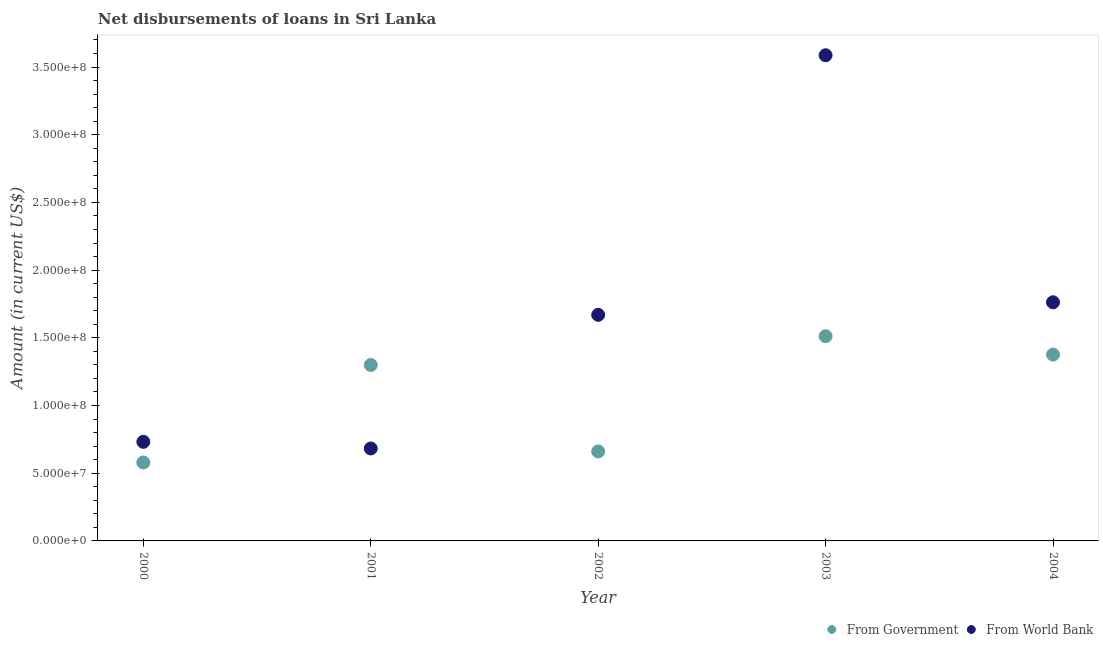How many different coloured dotlines are there?
Offer a very short reply. 2. What is the net disbursements of loan from government in 2004?
Make the answer very short. 1.38e+08. Across all years, what is the maximum net disbursements of loan from world bank?
Ensure brevity in your answer.  3.59e+08. Across all years, what is the minimum net disbursements of loan from world bank?
Ensure brevity in your answer.  6.83e+07. What is the total net disbursements of loan from government in the graph?
Offer a terse response. 5.43e+08. What is the difference between the net disbursements of loan from government in 2002 and that in 2003?
Give a very brief answer. -8.51e+07. What is the difference between the net disbursements of loan from world bank in 2003 and the net disbursements of loan from government in 2001?
Ensure brevity in your answer.  2.29e+08. What is the average net disbursements of loan from world bank per year?
Offer a very short reply. 1.69e+08. In the year 2000, what is the difference between the net disbursements of loan from world bank and net disbursements of loan from government?
Provide a short and direct response. 1.53e+07. What is the ratio of the net disbursements of loan from world bank in 2001 to that in 2003?
Your answer should be compact. 0.19. Is the net disbursements of loan from world bank in 2000 less than that in 2003?
Offer a very short reply. Yes. Is the difference between the net disbursements of loan from government in 2002 and 2004 greater than the difference between the net disbursements of loan from world bank in 2002 and 2004?
Ensure brevity in your answer.  No. What is the difference between the highest and the second highest net disbursements of loan from world bank?
Ensure brevity in your answer.  1.82e+08. What is the difference between the highest and the lowest net disbursements of loan from world bank?
Make the answer very short. 2.90e+08. Is the sum of the net disbursements of loan from government in 2000 and 2002 greater than the maximum net disbursements of loan from world bank across all years?
Ensure brevity in your answer.  No. Is the net disbursements of loan from world bank strictly less than the net disbursements of loan from government over the years?
Make the answer very short. No. How many dotlines are there?
Ensure brevity in your answer.  2. What is the difference between two consecutive major ticks on the Y-axis?
Give a very brief answer. 5.00e+07. Does the graph contain any zero values?
Provide a succinct answer. No. Does the graph contain grids?
Provide a succinct answer. No. How many legend labels are there?
Make the answer very short. 2. How are the legend labels stacked?
Offer a terse response. Horizontal. What is the title of the graph?
Keep it short and to the point. Net disbursements of loans in Sri Lanka. What is the Amount (in current US$) in From Government in 2000?
Your answer should be compact. 5.79e+07. What is the Amount (in current US$) in From World Bank in 2000?
Ensure brevity in your answer.  7.32e+07. What is the Amount (in current US$) in From Government in 2001?
Offer a terse response. 1.30e+08. What is the Amount (in current US$) in From World Bank in 2001?
Offer a very short reply. 6.83e+07. What is the Amount (in current US$) in From Government in 2002?
Ensure brevity in your answer.  6.61e+07. What is the Amount (in current US$) in From World Bank in 2002?
Give a very brief answer. 1.67e+08. What is the Amount (in current US$) in From Government in 2003?
Make the answer very short. 1.51e+08. What is the Amount (in current US$) in From World Bank in 2003?
Ensure brevity in your answer.  3.59e+08. What is the Amount (in current US$) in From Government in 2004?
Your answer should be very brief. 1.38e+08. What is the Amount (in current US$) of From World Bank in 2004?
Your answer should be compact. 1.76e+08. Across all years, what is the maximum Amount (in current US$) in From Government?
Offer a very short reply. 1.51e+08. Across all years, what is the maximum Amount (in current US$) of From World Bank?
Provide a short and direct response. 3.59e+08. Across all years, what is the minimum Amount (in current US$) of From Government?
Offer a very short reply. 5.79e+07. Across all years, what is the minimum Amount (in current US$) of From World Bank?
Make the answer very short. 6.83e+07. What is the total Amount (in current US$) of From Government in the graph?
Your response must be concise. 5.43e+08. What is the total Amount (in current US$) of From World Bank in the graph?
Your answer should be compact. 8.43e+08. What is the difference between the Amount (in current US$) in From Government in 2000 and that in 2001?
Make the answer very short. -7.20e+07. What is the difference between the Amount (in current US$) in From World Bank in 2000 and that in 2001?
Your answer should be very brief. 4.90e+06. What is the difference between the Amount (in current US$) of From Government in 2000 and that in 2002?
Ensure brevity in your answer.  -8.20e+06. What is the difference between the Amount (in current US$) of From World Bank in 2000 and that in 2002?
Make the answer very short. -9.38e+07. What is the difference between the Amount (in current US$) of From Government in 2000 and that in 2003?
Give a very brief answer. -9.33e+07. What is the difference between the Amount (in current US$) in From World Bank in 2000 and that in 2003?
Make the answer very short. -2.86e+08. What is the difference between the Amount (in current US$) in From Government in 2000 and that in 2004?
Ensure brevity in your answer.  -7.97e+07. What is the difference between the Amount (in current US$) of From World Bank in 2000 and that in 2004?
Ensure brevity in your answer.  -1.03e+08. What is the difference between the Amount (in current US$) of From Government in 2001 and that in 2002?
Provide a short and direct response. 6.38e+07. What is the difference between the Amount (in current US$) of From World Bank in 2001 and that in 2002?
Offer a very short reply. -9.87e+07. What is the difference between the Amount (in current US$) in From Government in 2001 and that in 2003?
Provide a succinct answer. -2.13e+07. What is the difference between the Amount (in current US$) in From World Bank in 2001 and that in 2003?
Offer a very short reply. -2.90e+08. What is the difference between the Amount (in current US$) in From Government in 2001 and that in 2004?
Your answer should be compact. -7.67e+06. What is the difference between the Amount (in current US$) of From World Bank in 2001 and that in 2004?
Provide a succinct answer. -1.08e+08. What is the difference between the Amount (in current US$) in From Government in 2002 and that in 2003?
Offer a terse response. -8.51e+07. What is the difference between the Amount (in current US$) in From World Bank in 2002 and that in 2003?
Offer a very short reply. -1.92e+08. What is the difference between the Amount (in current US$) in From Government in 2002 and that in 2004?
Your answer should be very brief. -7.15e+07. What is the difference between the Amount (in current US$) of From World Bank in 2002 and that in 2004?
Give a very brief answer. -9.26e+06. What is the difference between the Amount (in current US$) of From Government in 2003 and that in 2004?
Your answer should be compact. 1.36e+07. What is the difference between the Amount (in current US$) in From World Bank in 2003 and that in 2004?
Offer a terse response. 1.82e+08. What is the difference between the Amount (in current US$) in From Government in 2000 and the Amount (in current US$) in From World Bank in 2001?
Your response must be concise. -1.04e+07. What is the difference between the Amount (in current US$) of From Government in 2000 and the Amount (in current US$) of From World Bank in 2002?
Your answer should be very brief. -1.09e+08. What is the difference between the Amount (in current US$) of From Government in 2000 and the Amount (in current US$) of From World Bank in 2003?
Provide a short and direct response. -3.01e+08. What is the difference between the Amount (in current US$) of From Government in 2000 and the Amount (in current US$) of From World Bank in 2004?
Provide a succinct answer. -1.18e+08. What is the difference between the Amount (in current US$) of From Government in 2001 and the Amount (in current US$) of From World Bank in 2002?
Provide a short and direct response. -3.70e+07. What is the difference between the Amount (in current US$) of From Government in 2001 and the Amount (in current US$) of From World Bank in 2003?
Provide a short and direct response. -2.29e+08. What is the difference between the Amount (in current US$) of From Government in 2001 and the Amount (in current US$) of From World Bank in 2004?
Provide a short and direct response. -4.63e+07. What is the difference between the Amount (in current US$) in From Government in 2002 and the Amount (in current US$) in From World Bank in 2003?
Offer a very short reply. -2.93e+08. What is the difference between the Amount (in current US$) of From Government in 2002 and the Amount (in current US$) of From World Bank in 2004?
Ensure brevity in your answer.  -1.10e+08. What is the difference between the Amount (in current US$) of From Government in 2003 and the Amount (in current US$) of From World Bank in 2004?
Provide a short and direct response. -2.50e+07. What is the average Amount (in current US$) in From Government per year?
Make the answer very short. 1.09e+08. What is the average Amount (in current US$) of From World Bank per year?
Keep it short and to the point. 1.69e+08. In the year 2000, what is the difference between the Amount (in current US$) in From Government and Amount (in current US$) in From World Bank?
Your answer should be compact. -1.53e+07. In the year 2001, what is the difference between the Amount (in current US$) in From Government and Amount (in current US$) in From World Bank?
Your answer should be very brief. 6.17e+07. In the year 2002, what is the difference between the Amount (in current US$) of From Government and Amount (in current US$) of From World Bank?
Your answer should be very brief. -1.01e+08. In the year 2003, what is the difference between the Amount (in current US$) in From Government and Amount (in current US$) in From World Bank?
Offer a terse response. -2.08e+08. In the year 2004, what is the difference between the Amount (in current US$) in From Government and Amount (in current US$) in From World Bank?
Offer a terse response. -3.86e+07. What is the ratio of the Amount (in current US$) in From Government in 2000 to that in 2001?
Make the answer very short. 0.45. What is the ratio of the Amount (in current US$) of From World Bank in 2000 to that in 2001?
Offer a terse response. 1.07. What is the ratio of the Amount (in current US$) in From Government in 2000 to that in 2002?
Your answer should be compact. 0.88. What is the ratio of the Amount (in current US$) of From World Bank in 2000 to that in 2002?
Your response must be concise. 0.44. What is the ratio of the Amount (in current US$) in From Government in 2000 to that in 2003?
Provide a succinct answer. 0.38. What is the ratio of the Amount (in current US$) of From World Bank in 2000 to that in 2003?
Your answer should be very brief. 0.2. What is the ratio of the Amount (in current US$) in From Government in 2000 to that in 2004?
Your answer should be compact. 0.42. What is the ratio of the Amount (in current US$) of From World Bank in 2000 to that in 2004?
Offer a terse response. 0.42. What is the ratio of the Amount (in current US$) in From Government in 2001 to that in 2002?
Offer a very short reply. 1.97. What is the ratio of the Amount (in current US$) of From World Bank in 2001 to that in 2002?
Give a very brief answer. 0.41. What is the ratio of the Amount (in current US$) of From Government in 2001 to that in 2003?
Make the answer very short. 0.86. What is the ratio of the Amount (in current US$) of From World Bank in 2001 to that in 2003?
Keep it short and to the point. 0.19. What is the ratio of the Amount (in current US$) in From Government in 2001 to that in 2004?
Your answer should be very brief. 0.94. What is the ratio of the Amount (in current US$) in From World Bank in 2001 to that in 2004?
Provide a short and direct response. 0.39. What is the ratio of the Amount (in current US$) of From Government in 2002 to that in 2003?
Your answer should be compact. 0.44. What is the ratio of the Amount (in current US$) in From World Bank in 2002 to that in 2003?
Give a very brief answer. 0.47. What is the ratio of the Amount (in current US$) in From Government in 2002 to that in 2004?
Give a very brief answer. 0.48. What is the ratio of the Amount (in current US$) of From World Bank in 2002 to that in 2004?
Your answer should be compact. 0.95. What is the ratio of the Amount (in current US$) in From Government in 2003 to that in 2004?
Keep it short and to the point. 1.1. What is the ratio of the Amount (in current US$) in From World Bank in 2003 to that in 2004?
Make the answer very short. 2.04. What is the difference between the highest and the second highest Amount (in current US$) in From Government?
Offer a very short reply. 1.36e+07. What is the difference between the highest and the second highest Amount (in current US$) in From World Bank?
Make the answer very short. 1.82e+08. What is the difference between the highest and the lowest Amount (in current US$) in From Government?
Ensure brevity in your answer.  9.33e+07. What is the difference between the highest and the lowest Amount (in current US$) of From World Bank?
Give a very brief answer. 2.90e+08. 